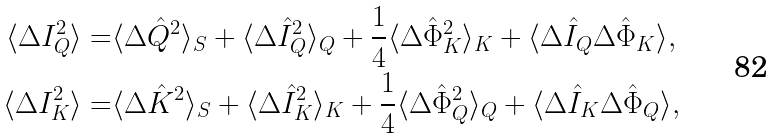<formula> <loc_0><loc_0><loc_500><loc_500>\langle \Delta I _ { Q } ^ { 2 } \rangle = & \langle \Delta \hat { Q } ^ { 2 } \rangle _ { S } + \langle \Delta \hat { I } _ { Q } ^ { 2 } \rangle _ { Q } + \frac { 1 } { 4 } \langle \Delta \hat { \Phi } _ { K } ^ { 2 } \rangle _ { K } + \langle \Delta \hat { I } _ { Q } \Delta \hat { \Phi } _ { K } \rangle , \\ \langle \Delta I _ { K } ^ { 2 } \rangle = & \langle \Delta \hat { K } ^ { 2 } \rangle _ { S } + \langle \Delta \hat { I } _ { K } ^ { 2 } \rangle _ { K } + \frac { 1 } { 4 } \langle \Delta \hat { \Phi } _ { Q } ^ { 2 } \rangle _ { Q } + \langle \Delta \hat { I } _ { K } \Delta \hat { \Phi } _ { Q } \rangle ,</formula> 